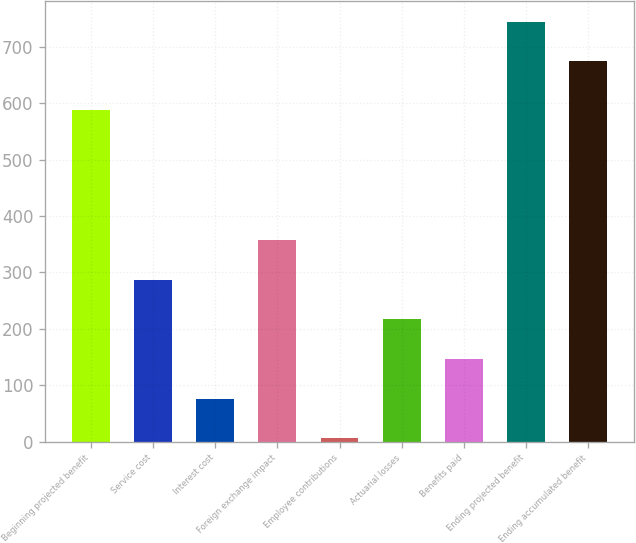<chart> <loc_0><loc_0><loc_500><loc_500><bar_chart><fcel>Beginning projected benefit<fcel>Service cost<fcel>Interest cost<fcel>Foreign exchange impact<fcel>Employee contributions<fcel>Actuarial losses<fcel>Benefits paid<fcel>Ending projected benefit<fcel>Ending accumulated benefit<nl><fcel>588<fcel>286.8<fcel>76.2<fcel>357<fcel>6<fcel>216.6<fcel>146.4<fcel>745.2<fcel>675<nl></chart> 